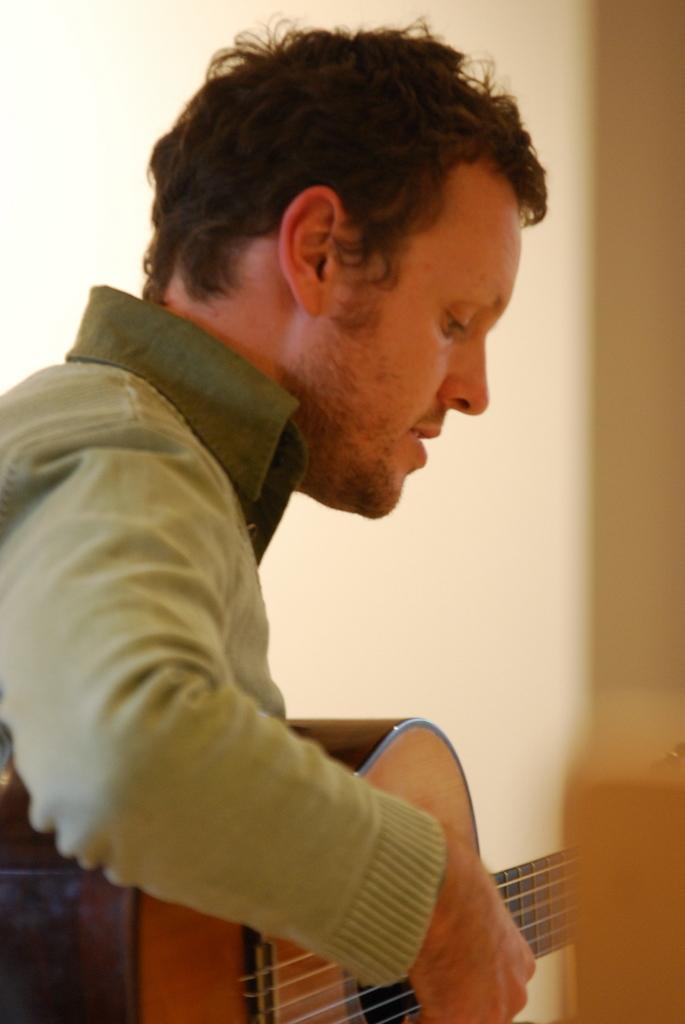Describe this image in one or two sentences. In this picture we can see a man holding guitar with his hand and playing it and in the background we can see wall. 